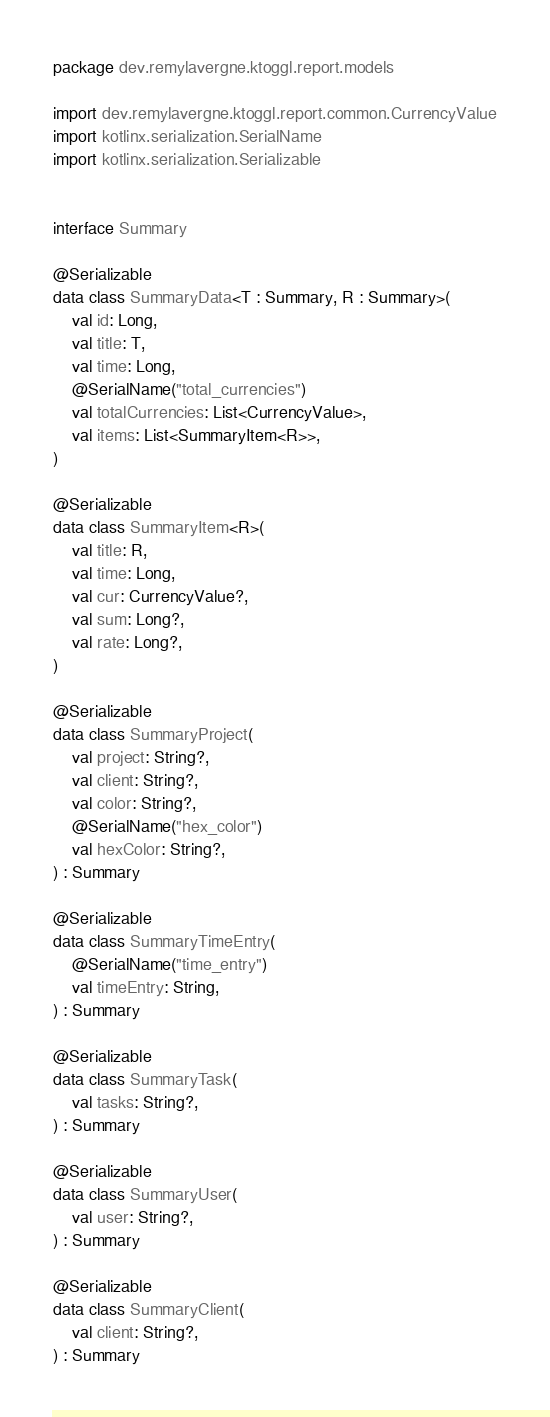Convert code to text. <code><loc_0><loc_0><loc_500><loc_500><_Kotlin_>package dev.remylavergne.ktoggl.report.models

import dev.remylavergne.ktoggl.report.common.CurrencyValue
import kotlinx.serialization.SerialName
import kotlinx.serialization.Serializable


interface Summary

@Serializable
data class SummaryData<T : Summary, R : Summary>(
    val id: Long,
    val title: T,
    val time: Long,
    @SerialName("total_currencies")
    val totalCurrencies: List<CurrencyValue>,
    val items: List<SummaryItem<R>>,
)

@Serializable
data class SummaryItem<R>(
    val title: R,
    val time: Long,
    val cur: CurrencyValue?,
    val sum: Long?,
    val rate: Long?,
)

@Serializable
data class SummaryProject(
    val project: String?,
    val client: String?,
    val color: String?,
    @SerialName("hex_color")
    val hexColor: String?,
) : Summary

@Serializable
data class SummaryTimeEntry(
    @SerialName("time_entry")
    val timeEntry: String,
) : Summary

@Serializable
data class SummaryTask(
    val tasks: String?,
) : Summary

@Serializable
data class SummaryUser(
    val user: String?,
) : Summary

@Serializable
data class SummaryClient(
    val client: String?,
) : Summary
</code> 